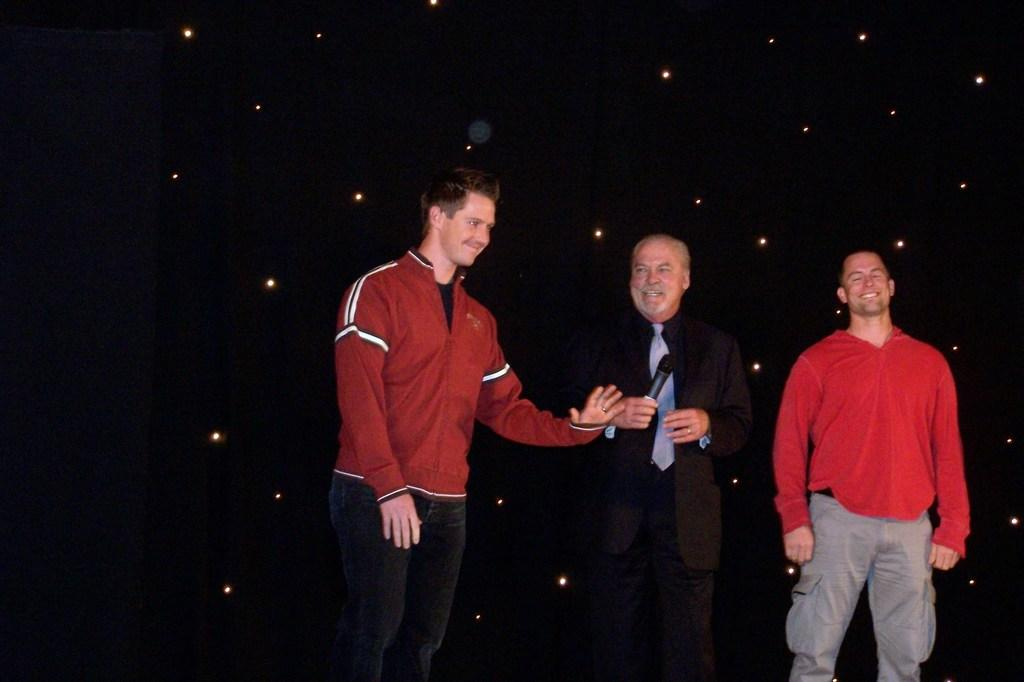How many people are in the image? There are persons standing in the image. What are the people wearing? The persons are wearing clothes. What can be seen in the image besides the people? There are lights visible in the image. What is the color of the background in the image? The background of the image is dark. What type of furniture is visible in the image? There is no furniture present in the image. What kind of plant can be seen growing in the image? There is no plant visible in the image. 